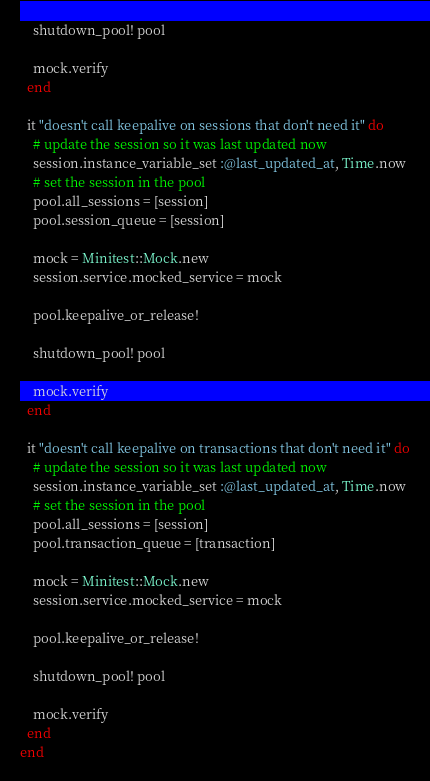<code> <loc_0><loc_0><loc_500><loc_500><_Ruby_>
    shutdown_pool! pool

    mock.verify
  end

  it "doesn't call keepalive on sessions that don't need it" do
    # update the session so it was last updated now
    session.instance_variable_set :@last_updated_at, Time.now
    # set the session in the pool
    pool.all_sessions = [session]
    pool.session_queue = [session]

    mock = Minitest::Mock.new
    session.service.mocked_service = mock

    pool.keepalive_or_release!

    shutdown_pool! pool

    mock.verify
  end

  it "doesn't call keepalive on transactions that don't need it" do
    # update the session so it was last updated now
    session.instance_variable_set :@last_updated_at, Time.now
    # set the session in the pool
    pool.all_sessions = [session]
    pool.transaction_queue = [transaction]

    mock = Minitest::Mock.new
    session.service.mocked_service = mock

    pool.keepalive_or_release!

    shutdown_pool! pool

    mock.verify
  end
end
</code> 